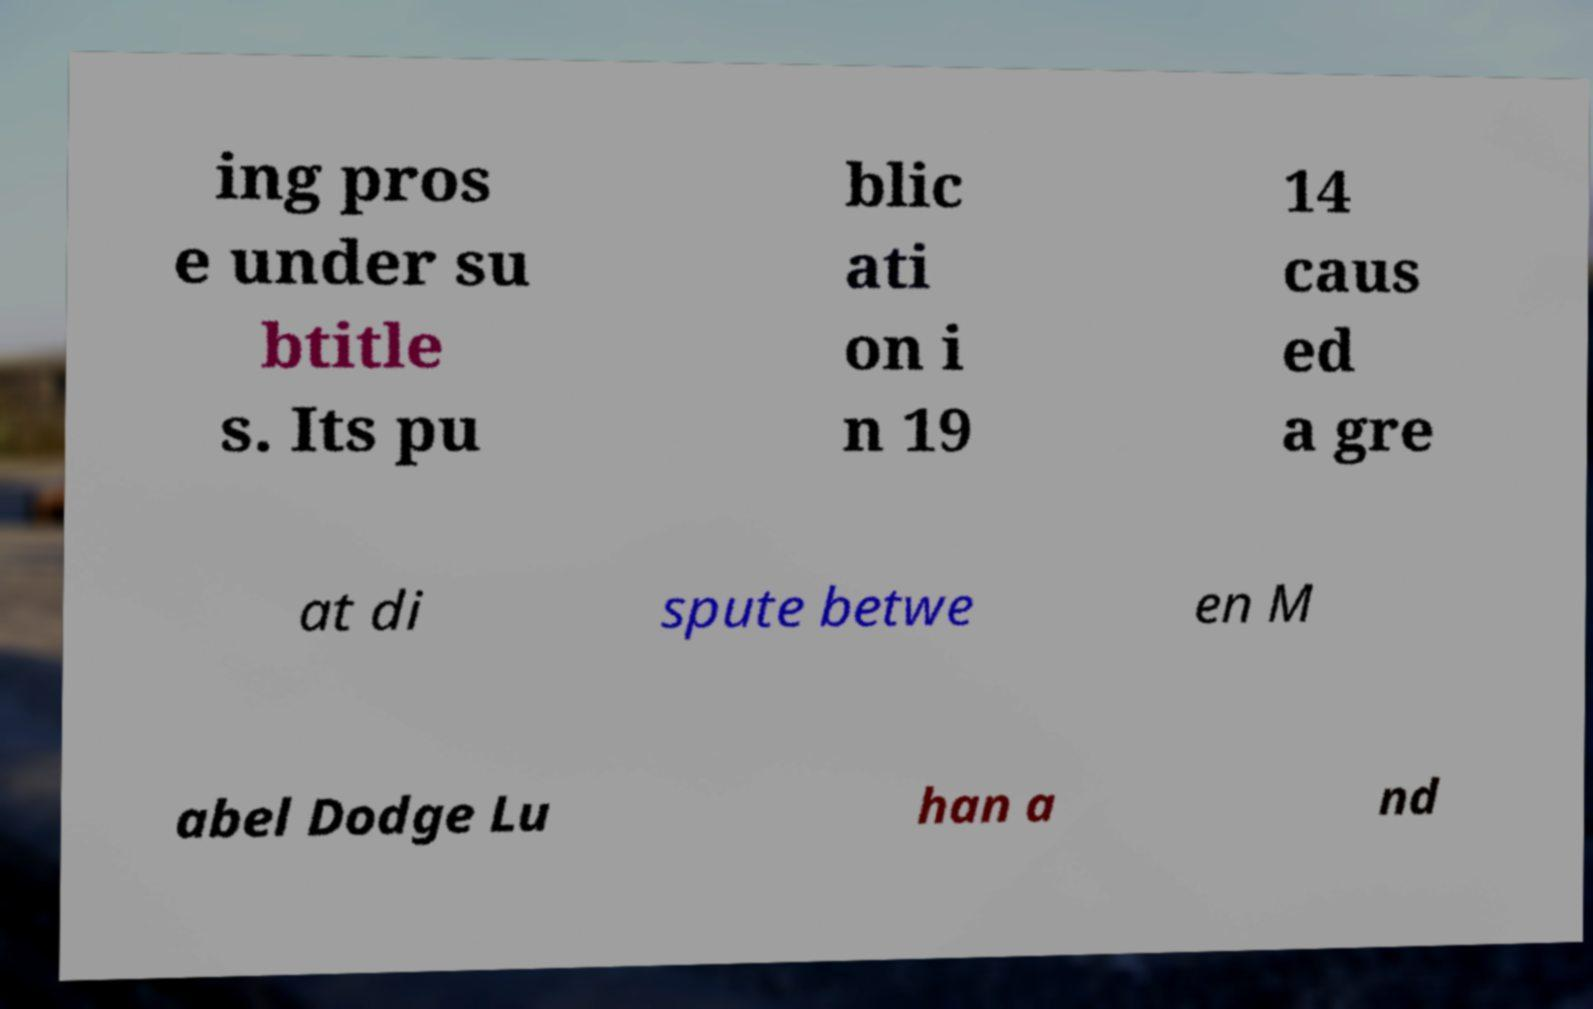I need the written content from this picture converted into text. Can you do that? ing pros e under su btitle s. Its pu blic ati on i n 19 14 caus ed a gre at di spute betwe en M abel Dodge Lu han a nd 